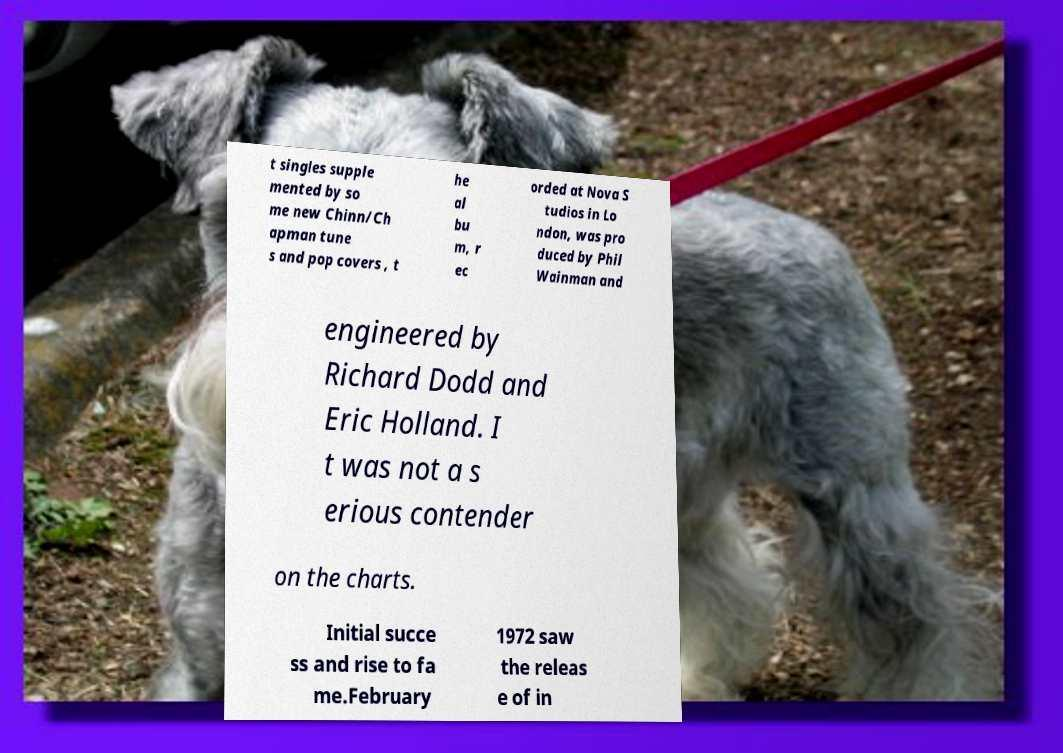There's text embedded in this image that I need extracted. Can you transcribe it verbatim? t singles supple mented by so me new Chinn/Ch apman tune s and pop covers , t he al bu m, r ec orded at Nova S tudios in Lo ndon, was pro duced by Phil Wainman and engineered by Richard Dodd and Eric Holland. I t was not a s erious contender on the charts. Initial succe ss and rise to fa me.February 1972 saw the releas e of in 